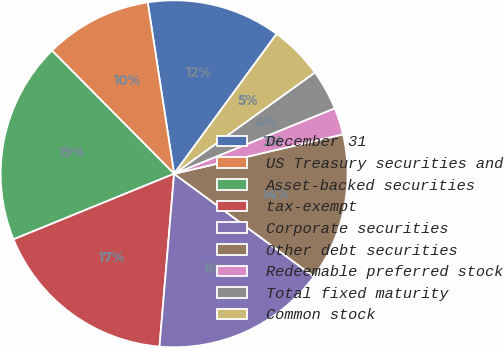<chart> <loc_0><loc_0><loc_500><loc_500><pie_chart><fcel>December 31<fcel>US Treasury securities and<fcel>Asset-backed securities<fcel>tax-exempt<fcel>Corporate securities<fcel>Other debt securities<fcel>Redeemable preferred stock<fcel>Total fixed maturity<fcel>Common stock<nl><fcel>12.5%<fcel>10.0%<fcel>18.74%<fcel>17.49%<fcel>16.25%<fcel>13.75%<fcel>2.51%<fcel>3.76%<fcel>5.01%<nl></chart> 